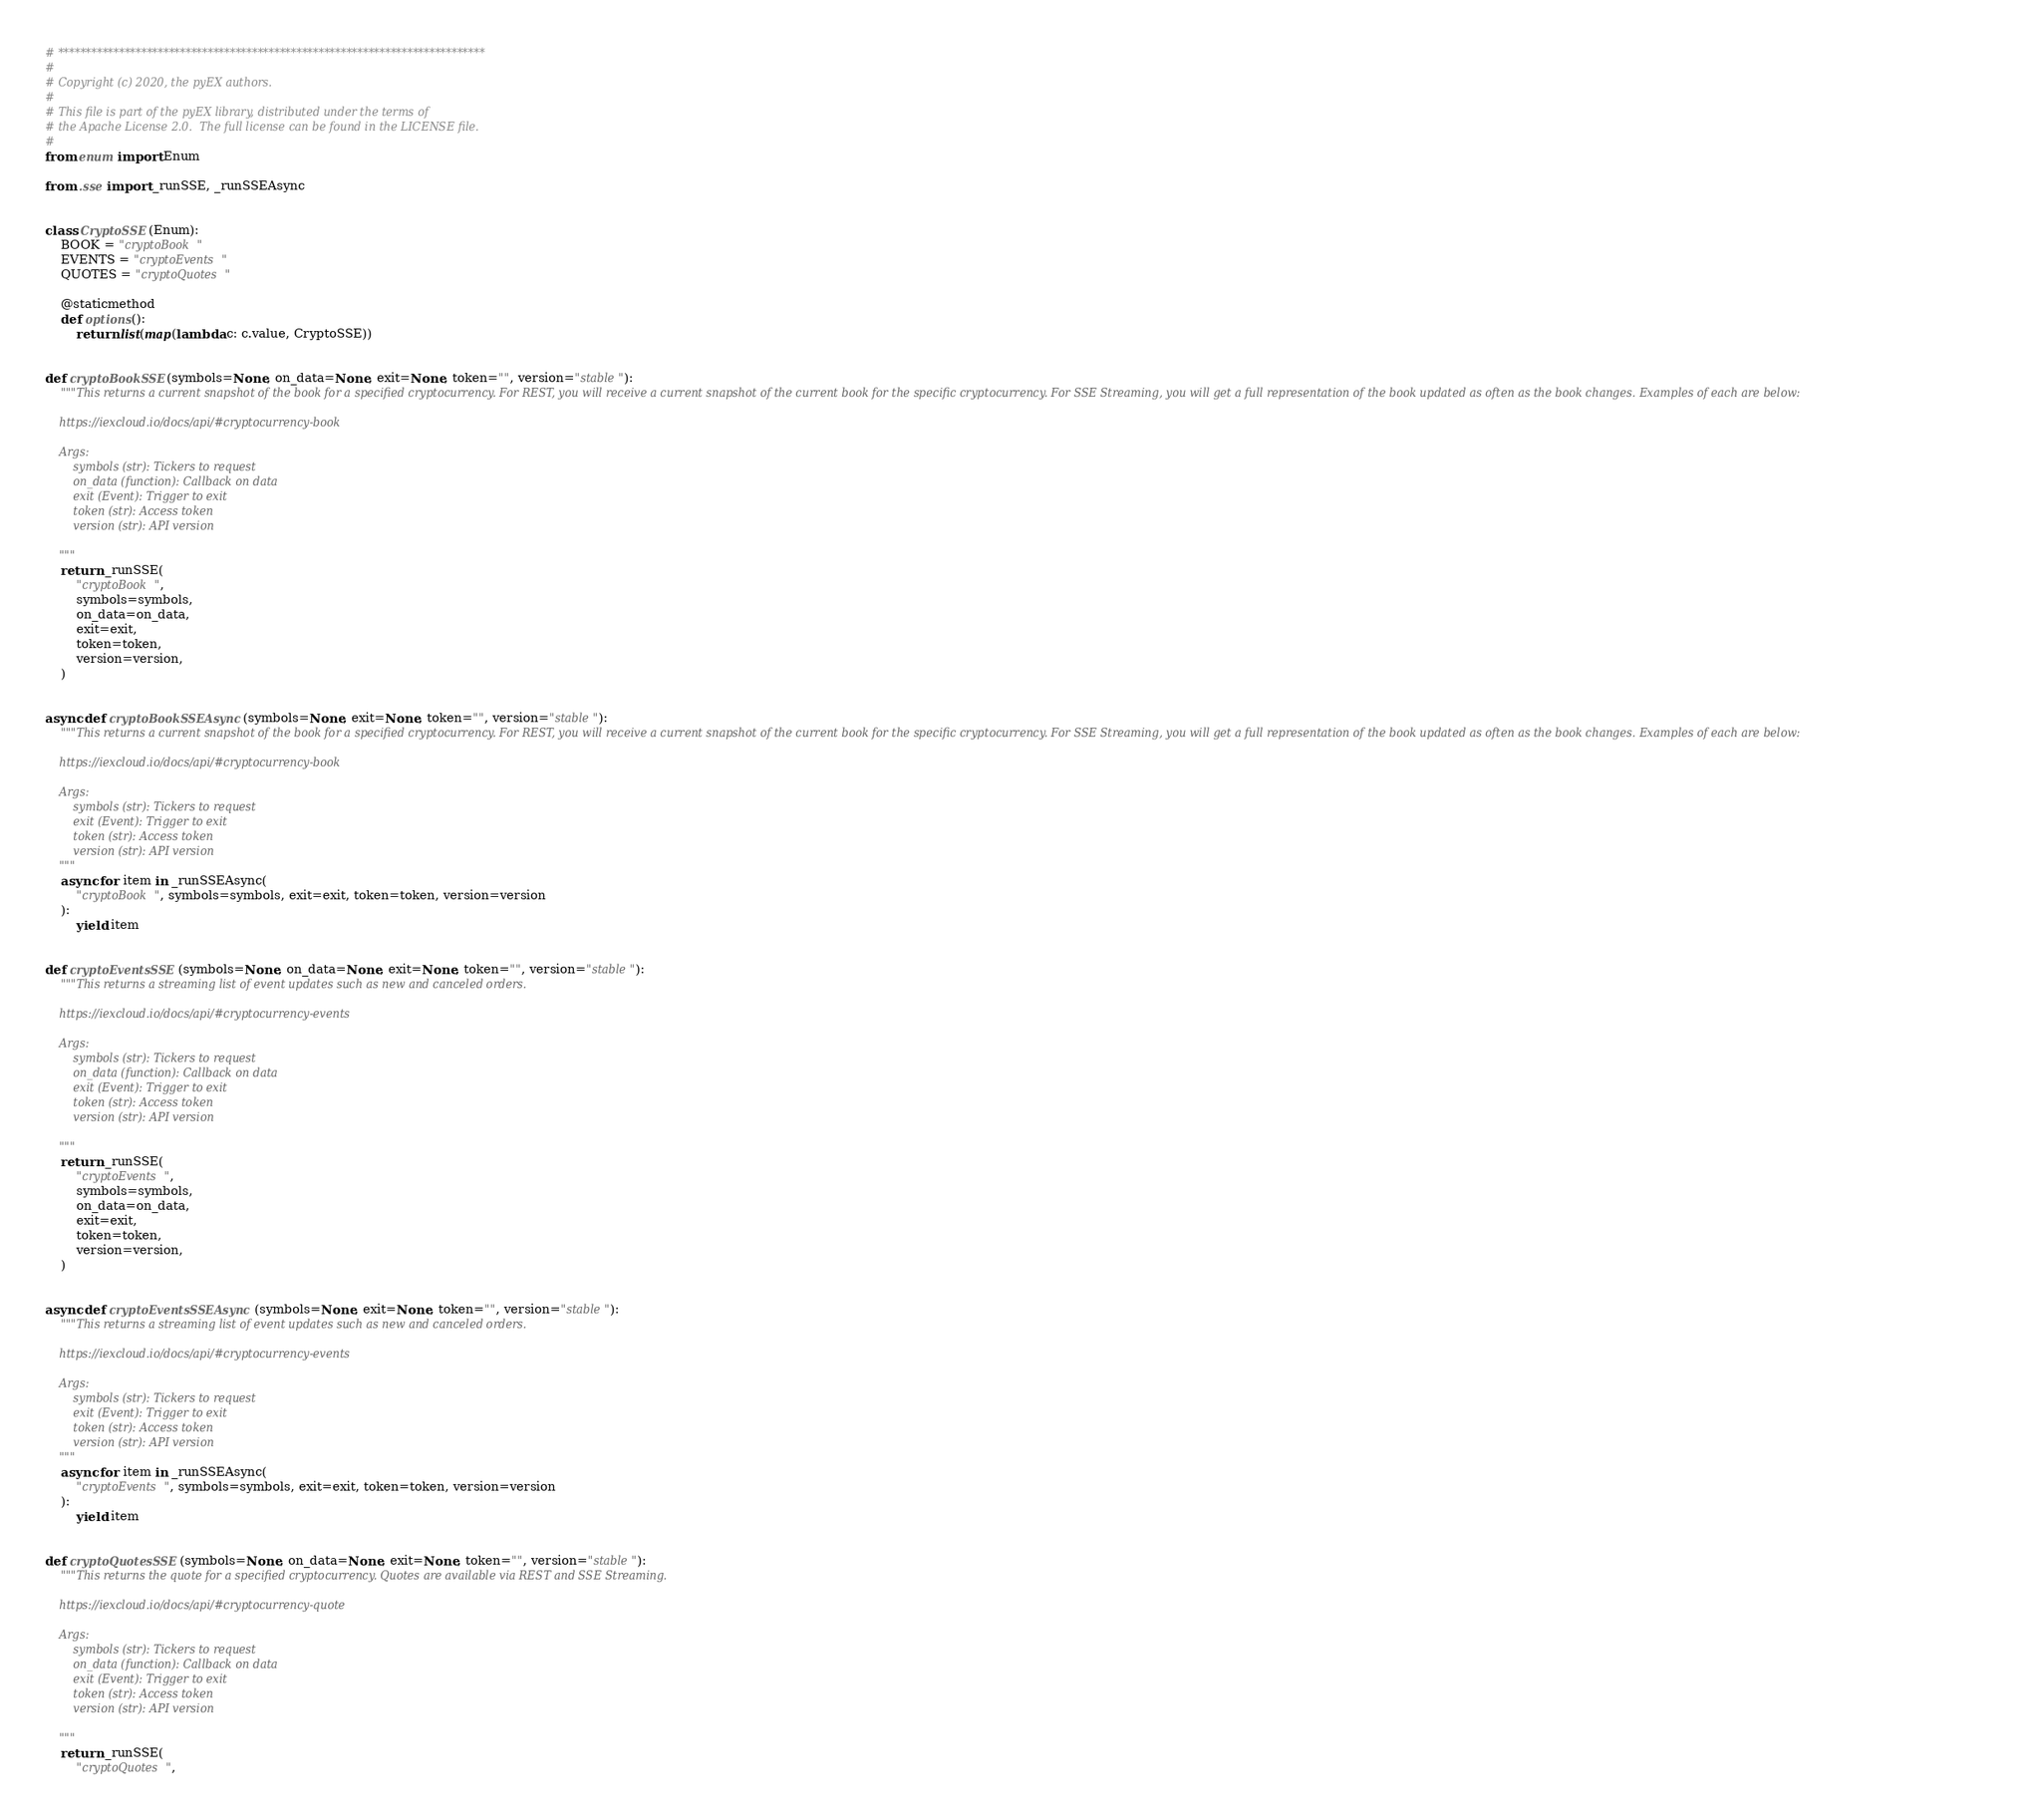Convert code to text. <code><loc_0><loc_0><loc_500><loc_500><_Python_># *****************************************************************************
#
# Copyright (c) 2020, the pyEX authors.
#
# This file is part of the pyEX library, distributed under the terms of
# the Apache License 2.0.  The full license can be found in the LICENSE file.
#
from enum import Enum

from .sse import _runSSE, _runSSEAsync


class CryptoSSE(Enum):
    BOOK = "cryptoBook"
    EVENTS = "cryptoEvents"
    QUOTES = "cryptoQuotes"

    @staticmethod
    def options():
        return list(map(lambda c: c.value, CryptoSSE))


def cryptoBookSSE(symbols=None, on_data=None, exit=None, token="", version="stable"):
    """This returns a current snapshot of the book for a specified cryptocurrency. For REST, you will receive a current snapshot of the current book for the specific cryptocurrency. For SSE Streaming, you will get a full representation of the book updated as often as the book changes. Examples of each are below:

    https://iexcloud.io/docs/api/#cryptocurrency-book

    Args:
        symbols (str): Tickers to request
        on_data (function): Callback on data
        exit (Event): Trigger to exit
        token (str): Access token
        version (str): API version

    """
    return _runSSE(
        "cryptoBook",
        symbols=symbols,
        on_data=on_data,
        exit=exit,
        token=token,
        version=version,
    )


async def cryptoBookSSEAsync(symbols=None, exit=None, token="", version="stable"):
    """This returns a current snapshot of the book for a specified cryptocurrency. For REST, you will receive a current snapshot of the current book for the specific cryptocurrency. For SSE Streaming, you will get a full representation of the book updated as often as the book changes. Examples of each are below:

    https://iexcloud.io/docs/api/#cryptocurrency-book

    Args:
        symbols (str): Tickers to request
        exit (Event): Trigger to exit
        token (str): Access token
        version (str): API version
    """
    async for item in _runSSEAsync(
        "cryptoBook", symbols=symbols, exit=exit, token=token, version=version
    ):
        yield item


def cryptoEventsSSE(symbols=None, on_data=None, exit=None, token="", version="stable"):
    """This returns a streaming list of event updates such as new and canceled orders.

    https://iexcloud.io/docs/api/#cryptocurrency-events

    Args:
        symbols (str): Tickers to request
        on_data (function): Callback on data
        exit (Event): Trigger to exit
        token (str): Access token
        version (str): API version

    """
    return _runSSE(
        "cryptoEvents",
        symbols=symbols,
        on_data=on_data,
        exit=exit,
        token=token,
        version=version,
    )


async def cryptoEventsSSEAsync(symbols=None, exit=None, token="", version="stable"):
    """This returns a streaming list of event updates such as new and canceled orders.

    https://iexcloud.io/docs/api/#cryptocurrency-events

    Args:
        symbols (str): Tickers to request
        exit (Event): Trigger to exit
        token (str): Access token
        version (str): API version
    """
    async for item in _runSSEAsync(
        "cryptoEvents", symbols=symbols, exit=exit, token=token, version=version
    ):
        yield item


def cryptoQuotesSSE(symbols=None, on_data=None, exit=None, token="", version="stable"):
    """This returns the quote for a specified cryptocurrency. Quotes are available via REST and SSE Streaming.

    https://iexcloud.io/docs/api/#cryptocurrency-quote

    Args:
        symbols (str): Tickers to request
        on_data (function): Callback on data
        exit (Event): Trigger to exit
        token (str): Access token
        version (str): API version

    """
    return _runSSE(
        "cryptoQuotes",</code> 